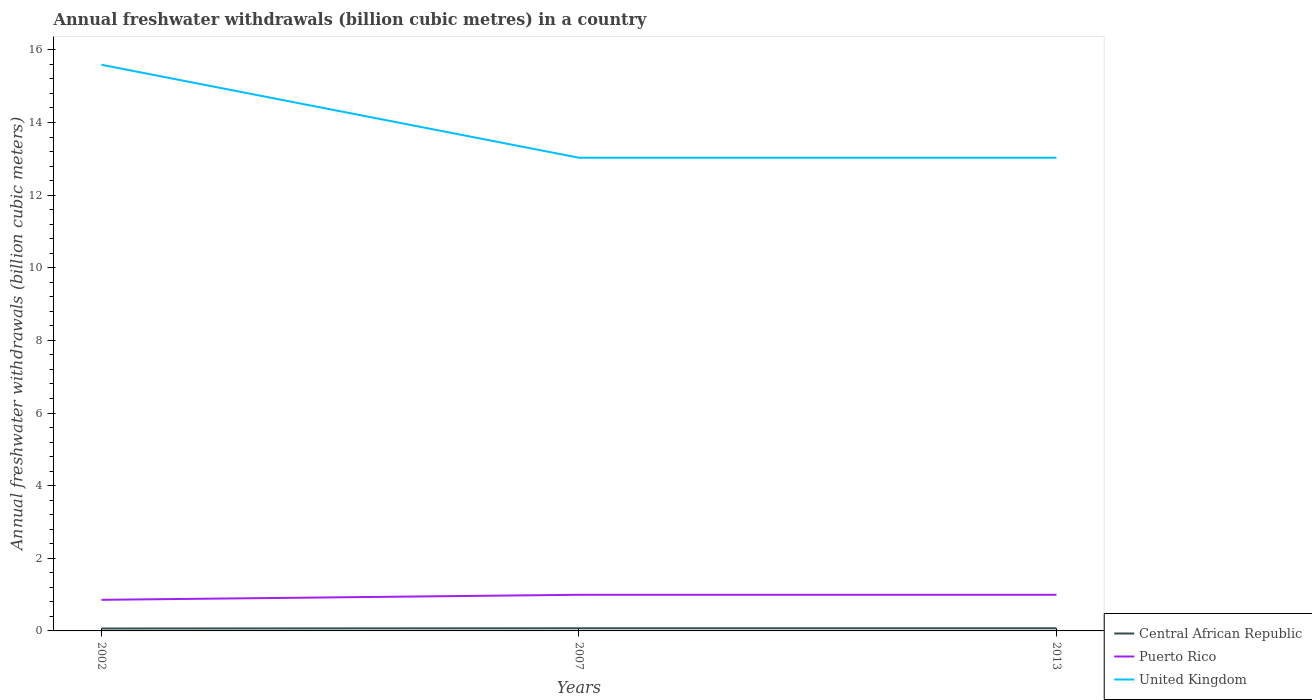How many different coloured lines are there?
Offer a terse response. 3. Does the line corresponding to Central African Republic intersect with the line corresponding to Puerto Rico?
Your answer should be compact. No. Is the number of lines equal to the number of legend labels?
Make the answer very short. Yes. Across all years, what is the maximum annual freshwater withdrawals in Puerto Rico?
Make the answer very short. 0.86. What is the total annual freshwater withdrawals in Puerto Rico in the graph?
Offer a very short reply. -0.14. What is the difference between the highest and the second highest annual freshwater withdrawals in Central African Republic?
Give a very brief answer. 0.01. Is the annual freshwater withdrawals in United Kingdom strictly greater than the annual freshwater withdrawals in Central African Republic over the years?
Your answer should be compact. No. How many lines are there?
Your answer should be compact. 3. How many years are there in the graph?
Your answer should be compact. 3. What is the difference between two consecutive major ticks on the Y-axis?
Offer a terse response. 2. Does the graph contain any zero values?
Make the answer very short. No. Does the graph contain grids?
Provide a succinct answer. No. How many legend labels are there?
Make the answer very short. 3. How are the legend labels stacked?
Provide a short and direct response. Vertical. What is the title of the graph?
Ensure brevity in your answer.  Annual freshwater withdrawals (billion cubic metres) in a country. Does "Channel Islands" appear as one of the legend labels in the graph?
Provide a short and direct response. No. What is the label or title of the Y-axis?
Keep it short and to the point. Annual freshwater withdrawals (billion cubic meters). What is the Annual freshwater withdrawals (billion cubic meters) of Central African Republic in 2002?
Provide a short and direct response. 0.07. What is the Annual freshwater withdrawals (billion cubic meters) in Puerto Rico in 2002?
Provide a short and direct response. 0.86. What is the Annual freshwater withdrawals (billion cubic meters) of United Kingdom in 2002?
Your answer should be very brief. 15.59. What is the Annual freshwater withdrawals (billion cubic meters) in Central African Republic in 2007?
Your response must be concise. 0.07. What is the Annual freshwater withdrawals (billion cubic meters) in Puerto Rico in 2007?
Make the answer very short. 0.99. What is the Annual freshwater withdrawals (billion cubic meters) of United Kingdom in 2007?
Your response must be concise. 13.03. What is the Annual freshwater withdrawals (billion cubic meters) in Central African Republic in 2013?
Ensure brevity in your answer.  0.07. What is the Annual freshwater withdrawals (billion cubic meters) in United Kingdom in 2013?
Your response must be concise. 13.03. Across all years, what is the maximum Annual freshwater withdrawals (billion cubic meters) of Central African Republic?
Offer a very short reply. 0.07. Across all years, what is the maximum Annual freshwater withdrawals (billion cubic meters) of Puerto Rico?
Offer a terse response. 0.99. Across all years, what is the maximum Annual freshwater withdrawals (billion cubic meters) of United Kingdom?
Your answer should be compact. 15.59. Across all years, what is the minimum Annual freshwater withdrawals (billion cubic meters) in Central African Republic?
Make the answer very short. 0.07. Across all years, what is the minimum Annual freshwater withdrawals (billion cubic meters) in Puerto Rico?
Ensure brevity in your answer.  0.86. Across all years, what is the minimum Annual freshwater withdrawals (billion cubic meters) of United Kingdom?
Make the answer very short. 13.03. What is the total Annual freshwater withdrawals (billion cubic meters) in Central African Republic in the graph?
Ensure brevity in your answer.  0.21. What is the total Annual freshwater withdrawals (billion cubic meters) in Puerto Rico in the graph?
Provide a succinct answer. 2.85. What is the total Annual freshwater withdrawals (billion cubic meters) of United Kingdom in the graph?
Make the answer very short. 41.65. What is the difference between the Annual freshwater withdrawals (billion cubic meters) of Central African Republic in 2002 and that in 2007?
Make the answer very short. -0.01. What is the difference between the Annual freshwater withdrawals (billion cubic meters) of Puerto Rico in 2002 and that in 2007?
Keep it short and to the point. -0.14. What is the difference between the Annual freshwater withdrawals (billion cubic meters) in United Kingdom in 2002 and that in 2007?
Give a very brief answer. 2.56. What is the difference between the Annual freshwater withdrawals (billion cubic meters) in Central African Republic in 2002 and that in 2013?
Your response must be concise. -0.01. What is the difference between the Annual freshwater withdrawals (billion cubic meters) of Puerto Rico in 2002 and that in 2013?
Give a very brief answer. -0.14. What is the difference between the Annual freshwater withdrawals (billion cubic meters) in United Kingdom in 2002 and that in 2013?
Your answer should be compact. 2.56. What is the difference between the Annual freshwater withdrawals (billion cubic meters) in Central African Republic in 2007 and that in 2013?
Your answer should be compact. 0. What is the difference between the Annual freshwater withdrawals (billion cubic meters) in United Kingdom in 2007 and that in 2013?
Offer a very short reply. 0. What is the difference between the Annual freshwater withdrawals (billion cubic meters) in Central African Republic in 2002 and the Annual freshwater withdrawals (billion cubic meters) in Puerto Rico in 2007?
Your answer should be compact. -0.93. What is the difference between the Annual freshwater withdrawals (billion cubic meters) in Central African Republic in 2002 and the Annual freshwater withdrawals (billion cubic meters) in United Kingdom in 2007?
Your response must be concise. -12.96. What is the difference between the Annual freshwater withdrawals (billion cubic meters) of Puerto Rico in 2002 and the Annual freshwater withdrawals (billion cubic meters) of United Kingdom in 2007?
Give a very brief answer. -12.17. What is the difference between the Annual freshwater withdrawals (billion cubic meters) in Central African Republic in 2002 and the Annual freshwater withdrawals (billion cubic meters) in Puerto Rico in 2013?
Keep it short and to the point. -0.93. What is the difference between the Annual freshwater withdrawals (billion cubic meters) of Central African Republic in 2002 and the Annual freshwater withdrawals (billion cubic meters) of United Kingdom in 2013?
Provide a short and direct response. -12.96. What is the difference between the Annual freshwater withdrawals (billion cubic meters) in Puerto Rico in 2002 and the Annual freshwater withdrawals (billion cubic meters) in United Kingdom in 2013?
Your answer should be compact. -12.17. What is the difference between the Annual freshwater withdrawals (billion cubic meters) in Central African Republic in 2007 and the Annual freshwater withdrawals (billion cubic meters) in Puerto Rico in 2013?
Make the answer very short. -0.92. What is the difference between the Annual freshwater withdrawals (billion cubic meters) of Central African Republic in 2007 and the Annual freshwater withdrawals (billion cubic meters) of United Kingdom in 2013?
Offer a terse response. -12.96. What is the difference between the Annual freshwater withdrawals (billion cubic meters) in Puerto Rico in 2007 and the Annual freshwater withdrawals (billion cubic meters) in United Kingdom in 2013?
Keep it short and to the point. -12.04. What is the average Annual freshwater withdrawals (billion cubic meters) in Central African Republic per year?
Your answer should be compact. 0.07. What is the average Annual freshwater withdrawals (billion cubic meters) in Puerto Rico per year?
Offer a very short reply. 0.95. What is the average Annual freshwater withdrawals (billion cubic meters) of United Kingdom per year?
Keep it short and to the point. 13.88. In the year 2002, what is the difference between the Annual freshwater withdrawals (billion cubic meters) in Central African Republic and Annual freshwater withdrawals (billion cubic meters) in Puerto Rico?
Your answer should be very brief. -0.79. In the year 2002, what is the difference between the Annual freshwater withdrawals (billion cubic meters) of Central African Republic and Annual freshwater withdrawals (billion cubic meters) of United Kingdom?
Your response must be concise. -15.52. In the year 2002, what is the difference between the Annual freshwater withdrawals (billion cubic meters) in Puerto Rico and Annual freshwater withdrawals (billion cubic meters) in United Kingdom?
Offer a terse response. -14.73. In the year 2007, what is the difference between the Annual freshwater withdrawals (billion cubic meters) in Central African Republic and Annual freshwater withdrawals (billion cubic meters) in Puerto Rico?
Make the answer very short. -0.92. In the year 2007, what is the difference between the Annual freshwater withdrawals (billion cubic meters) in Central African Republic and Annual freshwater withdrawals (billion cubic meters) in United Kingdom?
Your answer should be compact. -12.96. In the year 2007, what is the difference between the Annual freshwater withdrawals (billion cubic meters) of Puerto Rico and Annual freshwater withdrawals (billion cubic meters) of United Kingdom?
Ensure brevity in your answer.  -12.04. In the year 2013, what is the difference between the Annual freshwater withdrawals (billion cubic meters) of Central African Republic and Annual freshwater withdrawals (billion cubic meters) of Puerto Rico?
Your answer should be very brief. -0.92. In the year 2013, what is the difference between the Annual freshwater withdrawals (billion cubic meters) of Central African Republic and Annual freshwater withdrawals (billion cubic meters) of United Kingdom?
Provide a succinct answer. -12.96. In the year 2013, what is the difference between the Annual freshwater withdrawals (billion cubic meters) of Puerto Rico and Annual freshwater withdrawals (billion cubic meters) of United Kingdom?
Your answer should be compact. -12.04. What is the ratio of the Annual freshwater withdrawals (billion cubic meters) in Central African Republic in 2002 to that in 2007?
Keep it short and to the point. 0.91. What is the ratio of the Annual freshwater withdrawals (billion cubic meters) in Puerto Rico in 2002 to that in 2007?
Give a very brief answer. 0.86. What is the ratio of the Annual freshwater withdrawals (billion cubic meters) in United Kingdom in 2002 to that in 2007?
Keep it short and to the point. 1.2. What is the ratio of the Annual freshwater withdrawals (billion cubic meters) of Central African Republic in 2002 to that in 2013?
Your response must be concise. 0.91. What is the ratio of the Annual freshwater withdrawals (billion cubic meters) of Puerto Rico in 2002 to that in 2013?
Provide a short and direct response. 0.86. What is the ratio of the Annual freshwater withdrawals (billion cubic meters) in United Kingdom in 2002 to that in 2013?
Your answer should be very brief. 1.2. What is the ratio of the Annual freshwater withdrawals (billion cubic meters) of Central African Republic in 2007 to that in 2013?
Offer a very short reply. 1. What is the ratio of the Annual freshwater withdrawals (billion cubic meters) in Puerto Rico in 2007 to that in 2013?
Ensure brevity in your answer.  1. What is the difference between the highest and the second highest Annual freshwater withdrawals (billion cubic meters) of Central African Republic?
Offer a terse response. 0. What is the difference between the highest and the second highest Annual freshwater withdrawals (billion cubic meters) of United Kingdom?
Provide a succinct answer. 2.56. What is the difference between the highest and the lowest Annual freshwater withdrawals (billion cubic meters) of Central African Republic?
Your answer should be compact. 0.01. What is the difference between the highest and the lowest Annual freshwater withdrawals (billion cubic meters) of Puerto Rico?
Ensure brevity in your answer.  0.14. What is the difference between the highest and the lowest Annual freshwater withdrawals (billion cubic meters) in United Kingdom?
Your response must be concise. 2.56. 